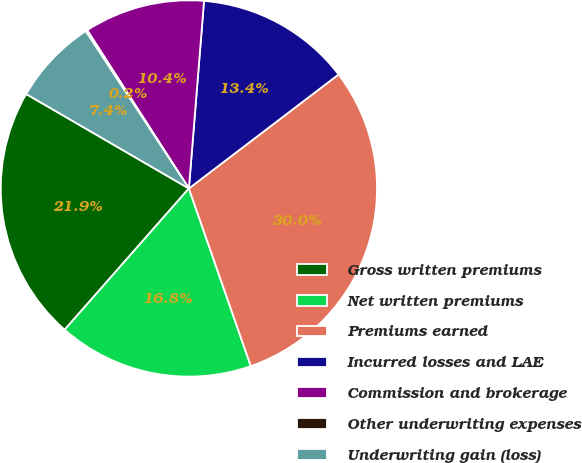Convert chart to OTSL. <chart><loc_0><loc_0><loc_500><loc_500><pie_chart><fcel>Gross written premiums<fcel>Net written premiums<fcel>Premiums earned<fcel>Incurred losses and LAE<fcel>Commission and brokerage<fcel>Other underwriting expenses<fcel>Underwriting gain (loss)<nl><fcel>21.89%<fcel>16.82%<fcel>30.02%<fcel>13.36%<fcel>10.37%<fcel>0.15%<fcel>7.39%<nl></chart> 